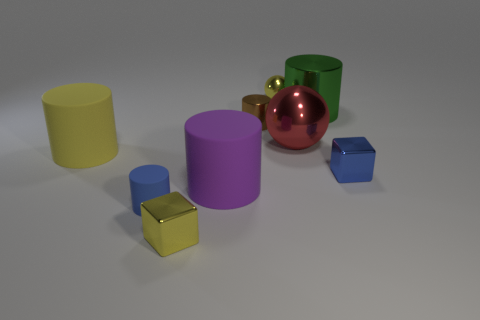Subtract all brown metal cylinders. How many cylinders are left? 4 Subtract all blue cylinders. How many cylinders are left? 4 Subtract all red cylinders. Subtract all brown blocks. How many cylinders are left? 5 Add 1 blue metallic things. How many objects exist? 10 Subtract all blocks. How many objects are left? 7 Subtract all tiny metallic things. Subtract all brown metal things. How many objects are left? 4 Add 7 blue objects. How many blue objects are left? 9 Add 3 small blue blocks. How many small blue blocks exist? 4 Subtract 1 purple cylinders. How many objects are left? 8 